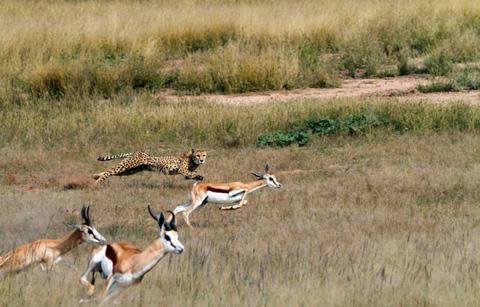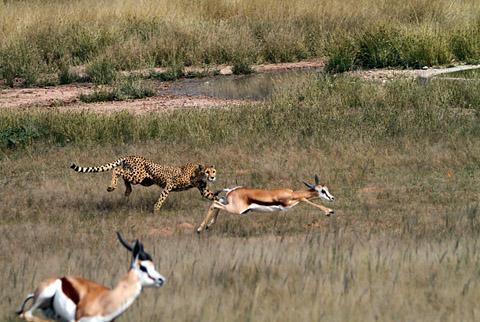The first image is the image on the left, the second image is the image on the right. For the images shown, is this caption "A single cheetah is chasing after a single prey in each image." true? Answer yes or no. No. The first image is the image on the left, the second image is the image on the right. Considering the images on both sides, is "All cheetahs appear to be actively chasing adult gazelles." valid? Answer yes or no. Yes. 